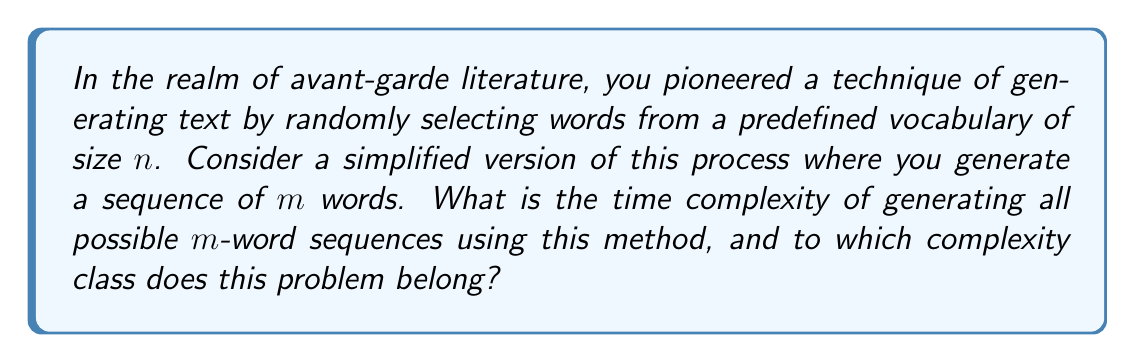Give your solution to this math problem. Let's approach this step-by-step:

1) For each position in the sequence, we have $n$ choices (the size of the vocabulary).

2) We need to make this choice $m$ times (the length of the sequence).

3) This is equivalent to creating all possible combinations of $m$ items, where each item can be one of $n$ possibilities.

4) The total number of possible sequences is thus $n^m$.

5) To generate all these sequences, we need to:
   a) Generate each sequence (which takes $O(m)$ time)
   b) Do this for all $n^m$ sequences

6) Therefore, the total time complexity is $O(m \cdot n^m)$.

7) This is an exponential time complexity with respect to $m$.

8) Problems with exponential time complexity typically belong to the complexity class EXPTIME.

9) More specifically, since this problem is a decision problem (we're asking about the existence of these sequences rather than optimizing something), it belongs to the complexity class EXP.

10) EXP is defined as the set of all decision problems solvable by a deterministic Turing machine in time $O(2^{p(n)})$, where $p(n)$ is a polynomial function of $n$.

11) Our complexity $O(m \cdot n^m)$ fits this definition, as we can consider $m$ as our input size, and $n$ as a constant (since the vocabulary size doesn't change).
Answer: The time complexity is $O(m \cdot n^m)$, and this problem belongs to the complexity class EXP. 